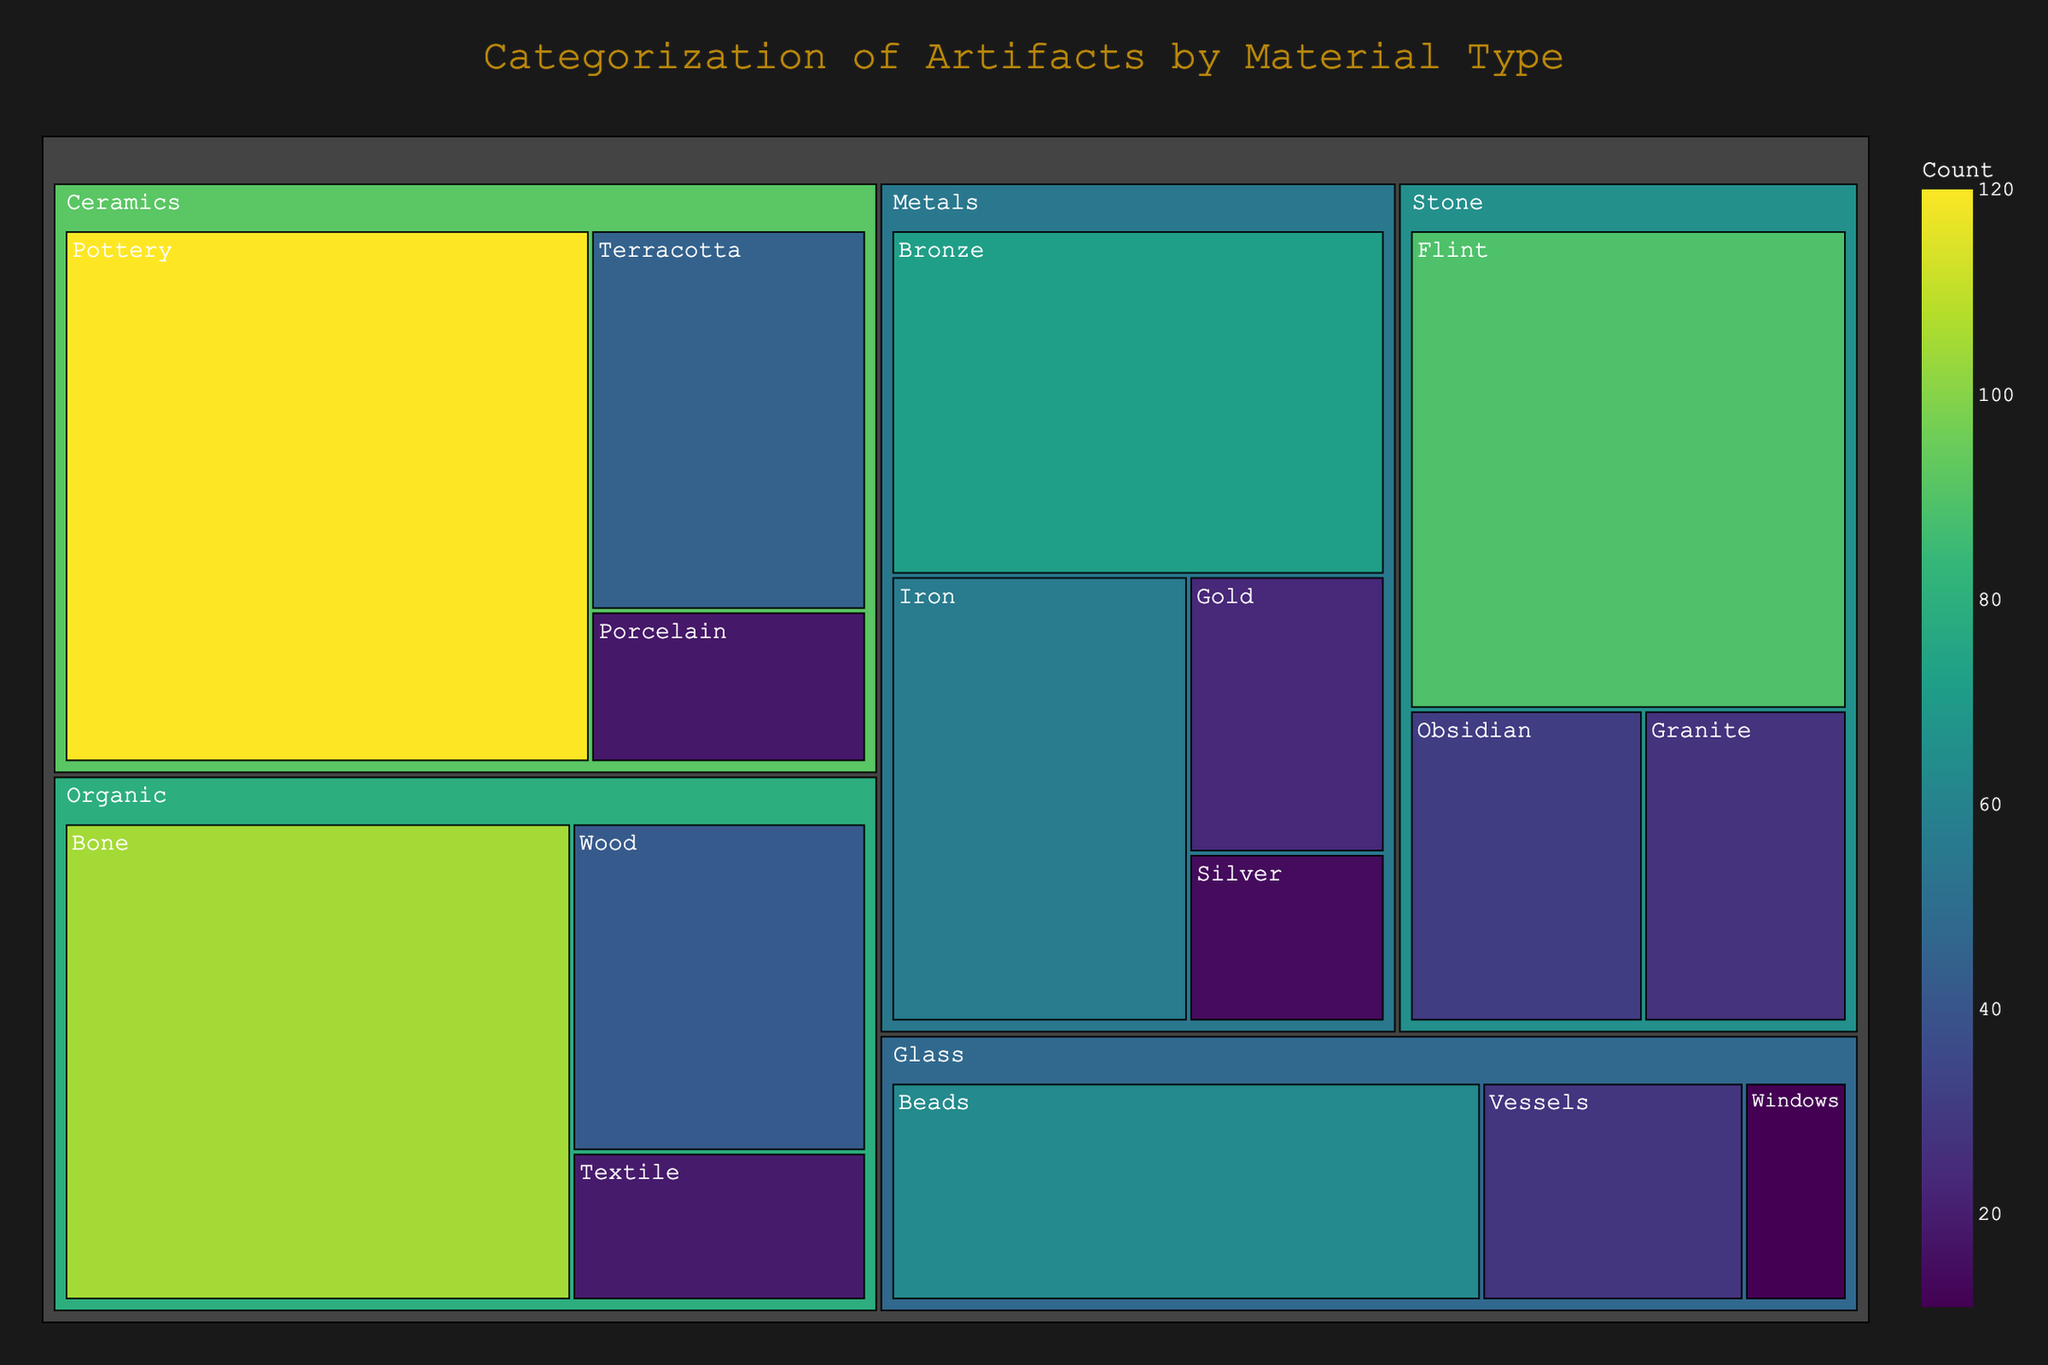What is the title of the treemap? The title is usually placed at the top of the figure and is often the largest text in the image. The title in this case is explicitly given in the plotting code.
Answer: Categorization of Artifacts by Material Type Which material has the highest count? Identify the material type with the largest value by examining the relative size of each cell in the treemap, or by checking the actual counts displayed on hover.
Answer: Pottery How many more Pottery artifacts are there than Iron artifacts? Find the counts for Pottery and Iron (120 and 56, respectively) and subtract the smaller count from the larger one to determine the difference.
Answer: 64 What is the total count of Ceramics artifacts? Sum the counts for all material types under the Ceramics category: Pottery (120), Terracotta (45), and Porcelain (18).
Answer: 183 Which category has the most diversity of materials? Count the number of different materials under each category by inspecting the treemap layout. Determine the category with the highest number of different materials.
Answer: Metals Which is greater, the count of Flint artifacts or Glass Beads? Compare the values given for Flint (89) and Glass Beads (63) to see which is larger.
Answer: Flint What is the average count of artifacts in the Organic category? Sum the counts for Bone (105), Wood (42), and Textile (19) and divide by the number of materials in the Organic category. (105 + 42 + 19) / 3 = 55.33
Answer: 55.33 How does the count of Bronze artifacts compare to the count of Iron artifacts? Compare the counts of Bronze (72) and Iron (56) directly to see which one is larger.
Answer: Bronze is greater Which material in the Glass category has the fewest artifacts? Look at the counts for all materials in the Glass category: Beads (63), Vessels (28), and Windows (11). Identify the smallest count.
Answer: Windows What is the proportional size of the Stone category compared to the overall count of artifacts? Sum the counts in the Stone category (Flint 89, Obsidian 31, Granite 27) to get 147. Then sum the counts of all artifacts: 720. Divide the Stone category count by the total count (147 / 720).
Answer: 20.4% 